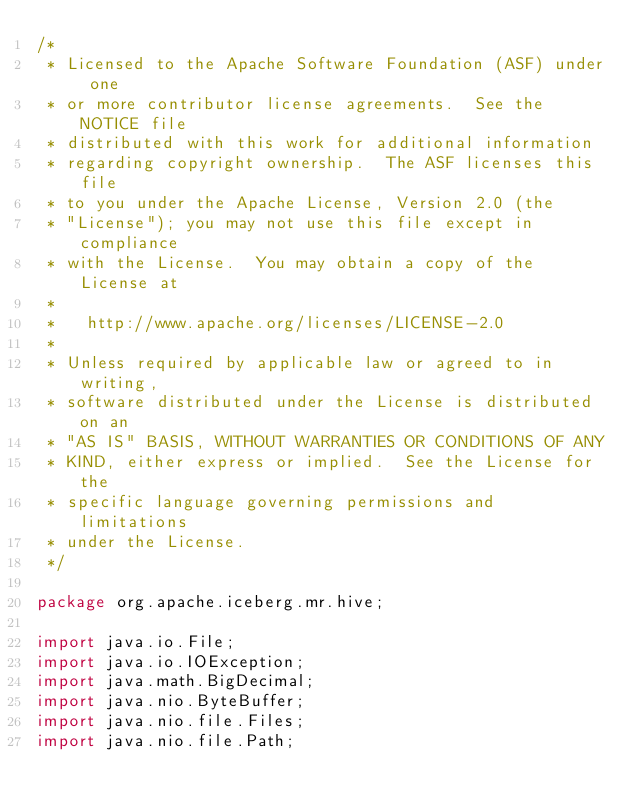<code> <loc_0><loc_0><loc_500><loc_500><_Java_>/*
 * Licensed to the Apache Software Foundation (ASF) under one
 * or more contributor license agreements.  See the NOTICE file
 * distributed with this work for additional information
 * regarding copyright ownership.  The ASF licenses this file
 * to you under the Apache License, Version 2.0 (the
 * "License"); you may not use this file except in compliance
 * with the License.  You may obtain a copy of the License at
 *
 *   http://www.apache.org/licenses/LICENSE-2.0
 *
 * Unless required by applicable law or agreed to in writing,
 * software distributed under the License is distributed on an
 * "AS IS" BASIS, WITHOUT WARRANTIES OR CONDITIONS OF ANY
 * KIND, either express or implied.  See the License for the
 * specific language governing permissions and limitations
 * under the License.
 */

package org.apache.iceberg.mr.hive;

import java.io.File;
import java.io.IOException;
import java.math.BigDecimal;
import java.nio.ByteBuffer;
import java.nio.file.Files;
import java.nio.file.Path;</code> 